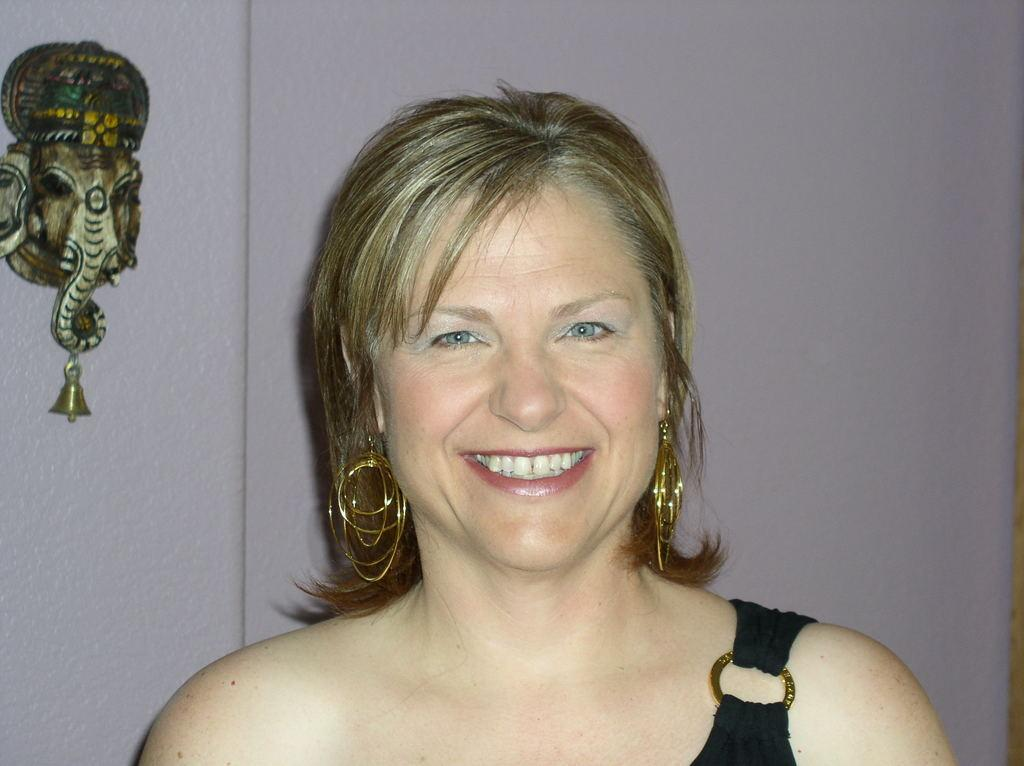Who is present in the image? There is a lady in the image. What is the lady doing in the image? The lady is smiling in the image. What can be seen in the background of the image? There is a wall in the background of the image. Is there any decoration on the wall in the background? Yes, there is a decoration placed on the wall in the background. What type of street can be seen in the image? There is no street visible in the image; it only features a lady, a wall, and a decoration on the wall. 